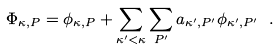<formula> <loc_0><loc_0><loc_500><loc_500>\Phi _ { \kappa , P } = \phi _ { \kappa , P } + \sum _ { \kappa ^ { \prime } < \kappa } \sum _ { P ^ { \prime } } a _ { \kappa ^ { \prime } , P ^ { \prime } } \phi _ { \kappa ^ { \prime } , P ^ { \prime } } \ .</formula> 